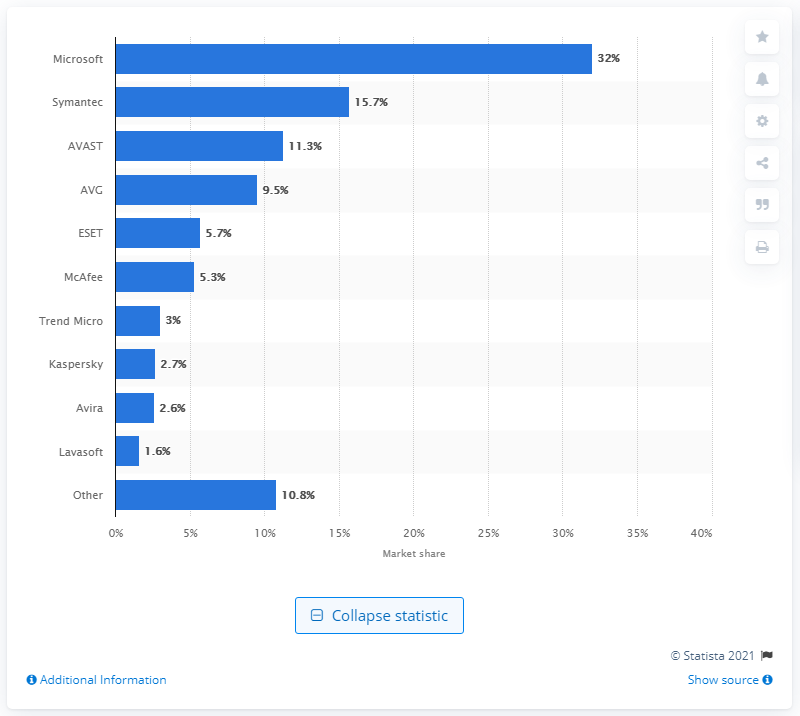Give some essential details in this illustration. As of May 2012 and November 2012, Microsoft held 32% of the North American antivirus application market. 